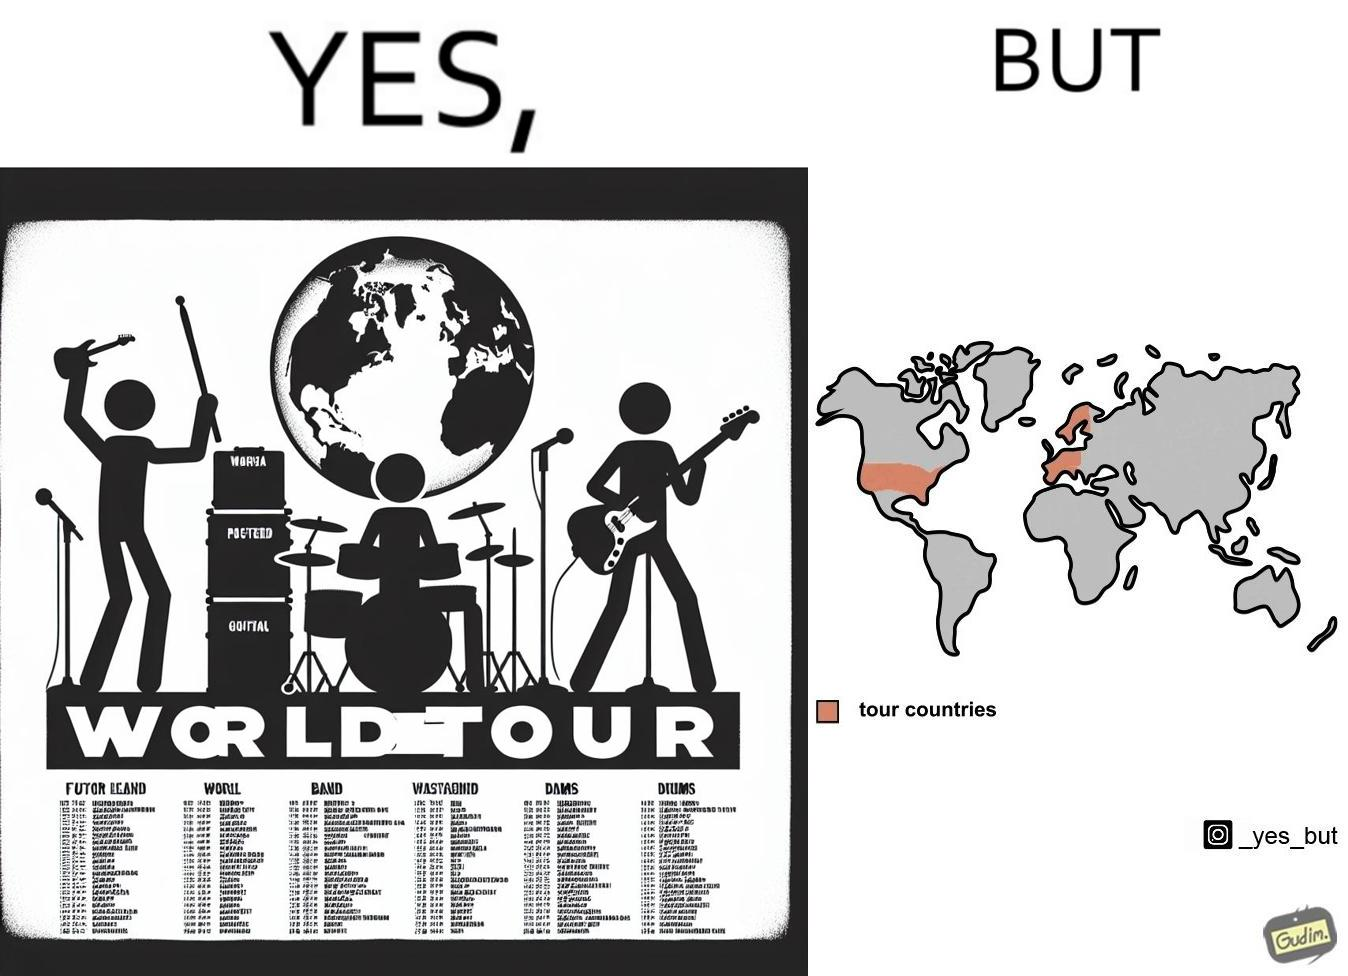What makes this image funny or satirical? The image is ironic, because in the first image some musical band is showing its poster of world tour but in the right image only a few countries are highlighted as tour countries 